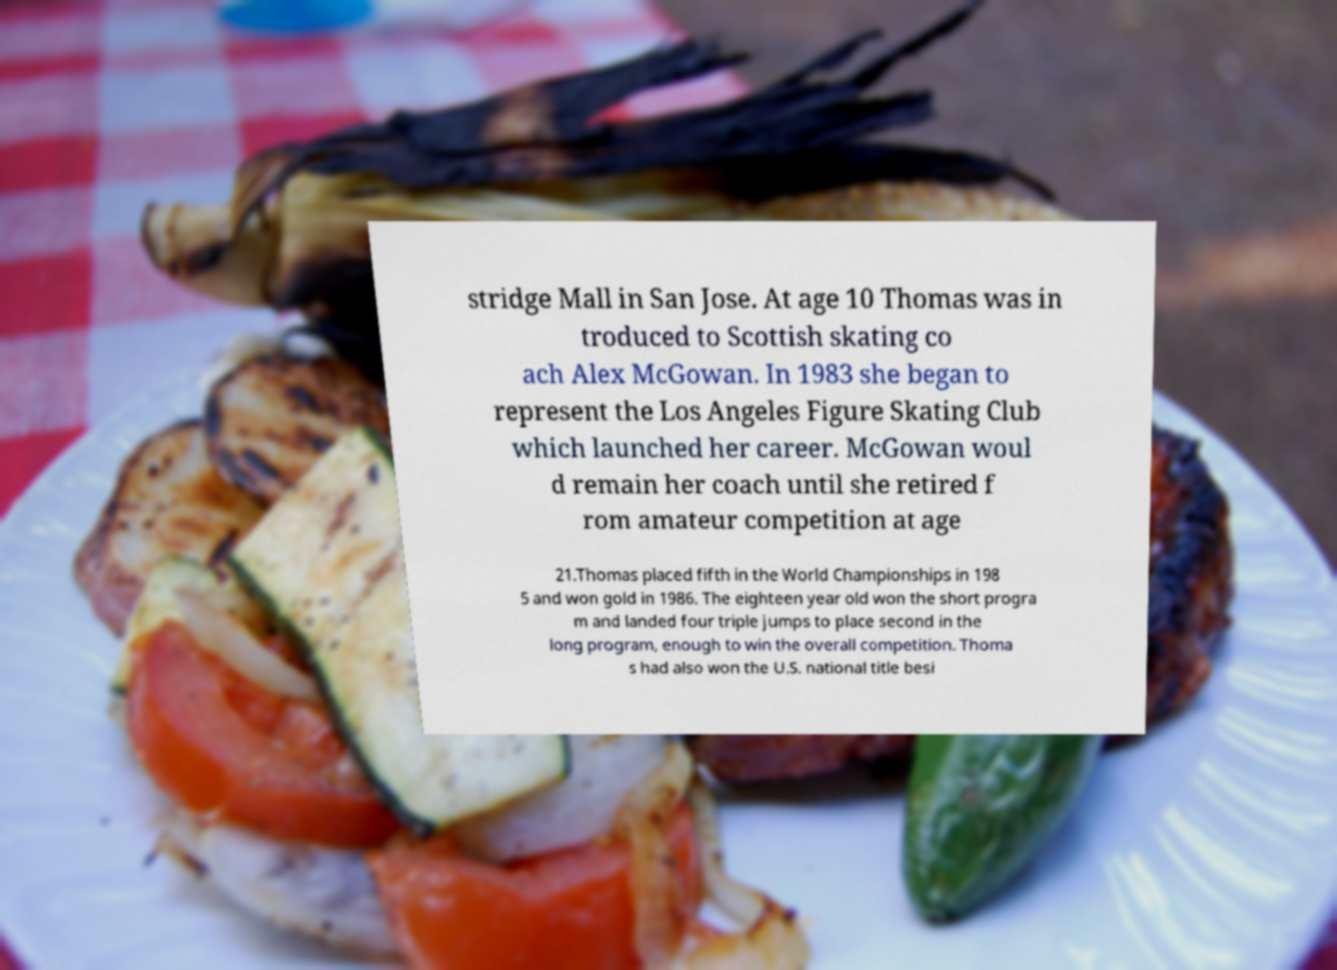I need the written content from this picture converted into text. Can you do that? stridge Mall in San Jose. At age 10 Thomas was in troduced to Scottish skating co ach Alex McGowan. In 1983 she began to represent the Los Angeles Figure Skating Club which launched her career. McGowan woul d remain her coach until she retired f rom amateur competition at age 21.Thomas placed fifth in the World Championships in 198 5 and won gold in 1986. The eighteen year old won the short progra m and landed four triple jumps to place second in the long program, enough to win the overall competition. Thoma s had also won the U.S. national title besi 